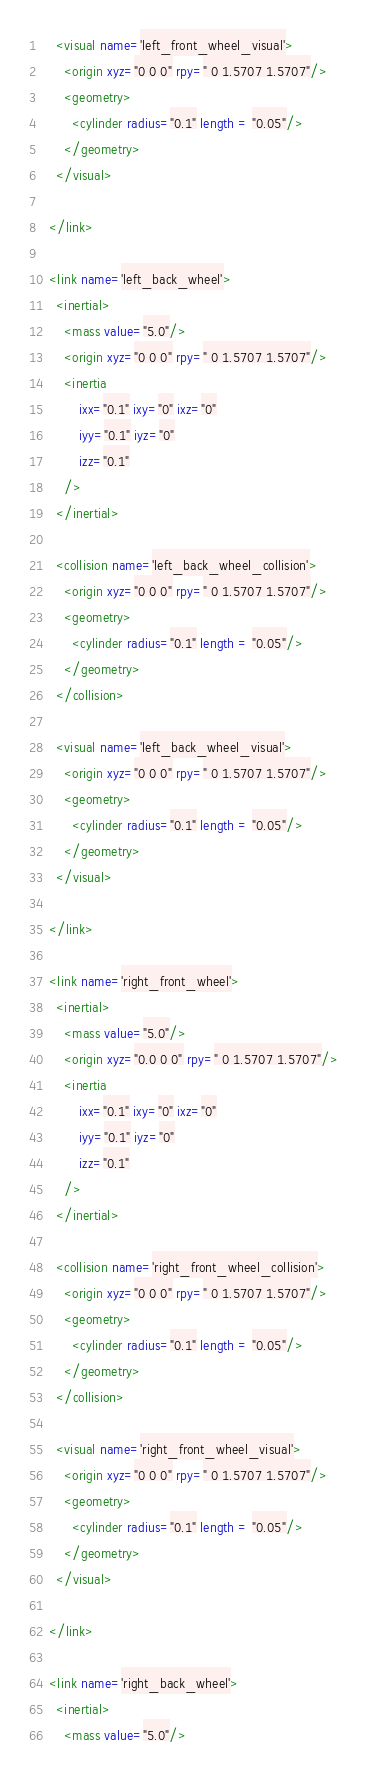<code> <loc_0><loc_0><loc_500><loc_500><_XML_>    <visual name='left_front_wheel_visual'>
      <origin xyz="0 0 0" rpy=" 0 1.5707 1.5707"/>
      <geometry>
        <cylinder radius="0.1" length = "0.05"/>
      </geometry>
    </visual>

  </link>

  <link name='left_back_wheel'>
    <inertial>
      <mass value="5.0"/>
      <origin xyz="0 0 0" rpy=" 0 1.5707 1.5707"/>
      <inertia
          ixx="0.1" ixy="0" ixz="0"
          iyy="0.1" iyz="0"
          izz="0.1"
      />
    </inertial>

    <collision name='left_back_wheel_collision'>
      <origin xyz="0 0 0" rpy=" 0 1.5707 1.5707"/>
      <geometry>
        <cylinder radius="0.1" length = "0.05"/>
      </geometry>
    </collision>

    <visual name='left_back_wheel_visual'>
      <origin xyz="0 0 0" rpy=" 0 1.5707 1.5707"/>
      <geometry>
        <cylinder radius="0.1" length = "0.05"/>
      </geometry>
    </visual>

  </link>

  <link name='right_front_wheel'>
    <inertial>
      <mass value="5.0"/>
      <origin xyz="0.0 0 0" rpy=" 0 1.5707 1.5707"/>
      <inertia
          ixx="0.1" ixy="0" ixz="0"
          iyy="0.1" iyz="0"
          izz="0.1"
      />
    </inertial>

    <collision name='right_front_wheel_collision'>
      <origin xyz="0 0 0" rpy=" 0 1.5707 1.5707"/>
      <geometry>
        <cylinder radius="0.1" length = "0.05"/>
      </geometry>
    </collision>

    <visual name='right_front_wheel_visual'>
      <origin xyz="0 0 0" rpy=" 0 1.5707 1.5707"/>
      <geometry>
        <cylinder radius="0.1" length = "0.05"/>
      </geometry>
    </visual>

  </link>

  <link name='right_back_wheel'>
    <inertial>
      <mass value="5.0"/></code> 